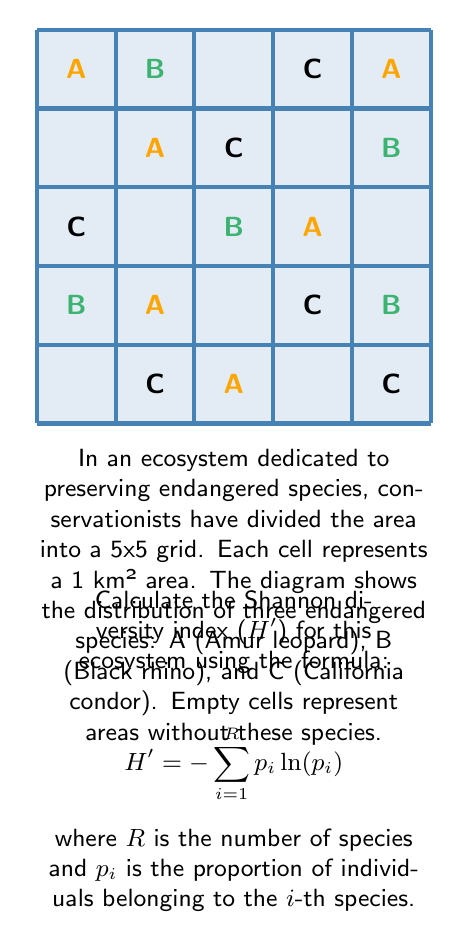Provide a solution to this math problem. To calculate the Shannon diversity index, we need to follow these steps:

1. Count the number of occurrences for each species:
   A (Amur leopard): 6
   B (Black rhino): 4
   C (California condor): 5

2. Calculate the total number of individuals:
   6 + 4 + 5 = 15

3. Calculate the proportion ($p_i$) for each species:
   $p_A = 6/15 = 0.4$
   $p_B = 4/15 \approx 0.2667$
   $p_C = 5/15 \approx 0.3333$

4. Calculate $p_i \ln(p_i)$ for each species:
   A: $0.4 \ln(0.4) \approx -0.3665$
   B: $0.2667 \ln(0.2667) \approx -0.3516$
   C: $0.3333 \ln(0.3333) \approx -0.3662$

5. Sum the negative values:
   $H' = -(-0.3665 - 0.3516 - 0.3662)$

6. Calculate the final result:
   $H' \approx 1.0843$

This value represents the Shannon diversity index for the given ecosystem, indicating the species richness and evenness of distribution.
Answer: $H' \approx 1.0843$ 